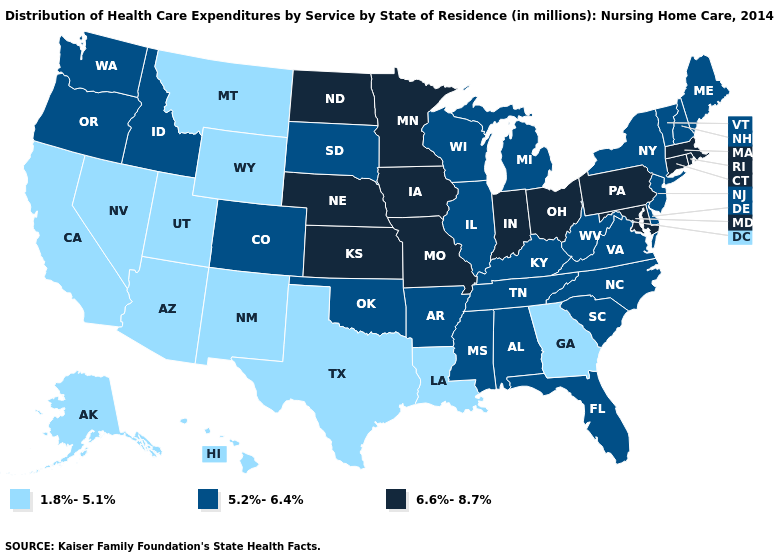What is the value of Wisconsin?
Concise answer only. 5.2%-6.4%. What is the value of Tennessee?
Answer briefly. 5.2%-6.4%. What is the value of Georgia?
Be succinct. 1.8%-5.1%. What is the lowest value in states that border New Mexico?
Give a very brief answer. 1.8%-5.1%. Does the map have missing data?
Give a very brief answer. No. What is the lowest value in the USA?
Quick response, please. 1.8%-5.1%. Does Pennsylvania have the highest value in the USA?
Keep it brief. Yes. What is the highest value in states that border Idaho?
Concise answer only. 5.2%-6.4%. What is the value of New Jersey?
Keep it brief. 5.2%-6.4%. What is the value of Alaska?
Keep it brief. 1.8%-5.1%. Does Louisiana have the lowest value in the USA?
Keep it brief. Yes. What is the value of Nevada?
Short answer required. 1.8%-5.1%. What is the highest value in the South ?
Concise answer only. 6.6%-8.7%. What is the lowest value in the MidWest?
Concise answer only. 5.2%-6.4%. Is the legend a continuous bar?
Give a very brief answer. No. 